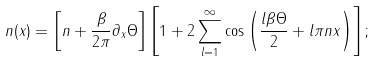<formula> <loc_0><loc_0><loc_500><loc_500>n ( x ) = \left [ n + \frac { \beta } { 2 \pi } \partial _ { x } \Theta \right ] \left [ 1 + 2 \sum _ { l = 1 } ^ { \infty } \cos \left ( \frac { l \beta \Theta } { 2 } + l \pi n x \right ) \right ] ;</formula> 